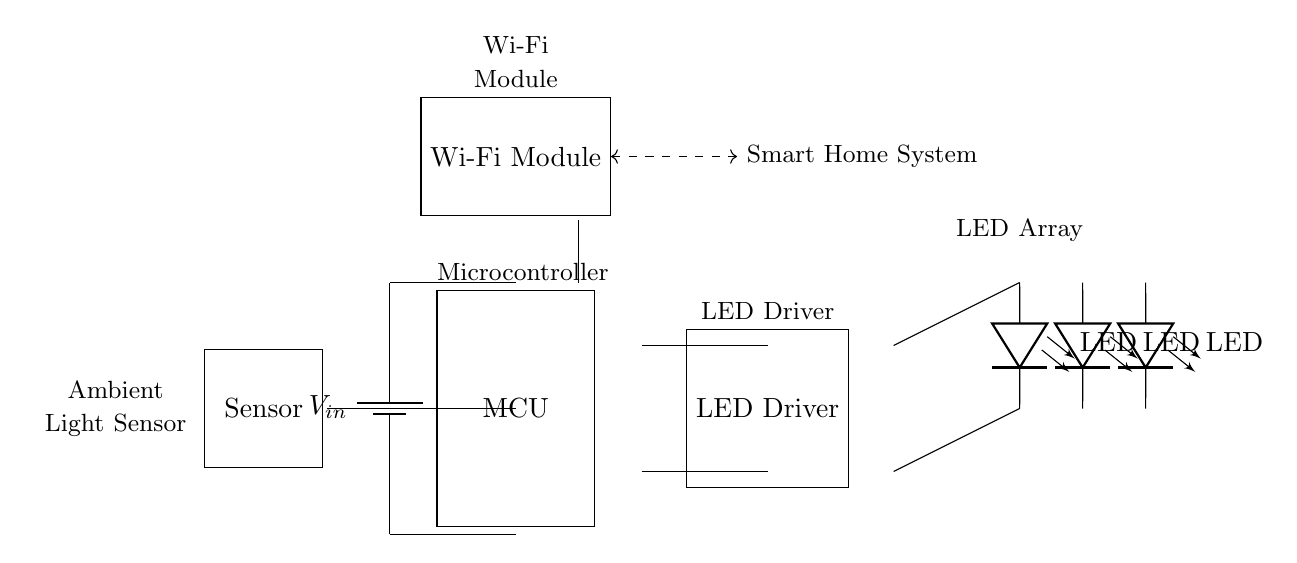What is the main power source for the circuit? The main power source is a battery labeled as V in, located at the top left of the circuit diagram.
Answer: Battery How many LEDs are included in this circuit? The circuit diagram shows three LEDs depicted in series, each marked as LED, located on the right side.
Answer: Three What component connects to the smart home system? The Wi-Fi module connects to the smart home system, indicated by a dashed connection with the label smart home system.
Answer: Wi-Fi module What component processes the sensor data? The microcontroller processes the sensor data, as it is directly connected to the ambient light sensor and controls the LED driver.
Answer: Microcontroller Which component regulates the LED operation? The LED driver regulates the LED operation, as it is specifically designed for driving the LED array shown in the circuit.
Answer: LED driver Why is the ambient light sensor used in this circuit? The ambient light sensor enables automatic adjustments of the LED brightness based on surrounding light levels, optimizing energy efficiency and user comfort.
Answer: Energy efficiency 